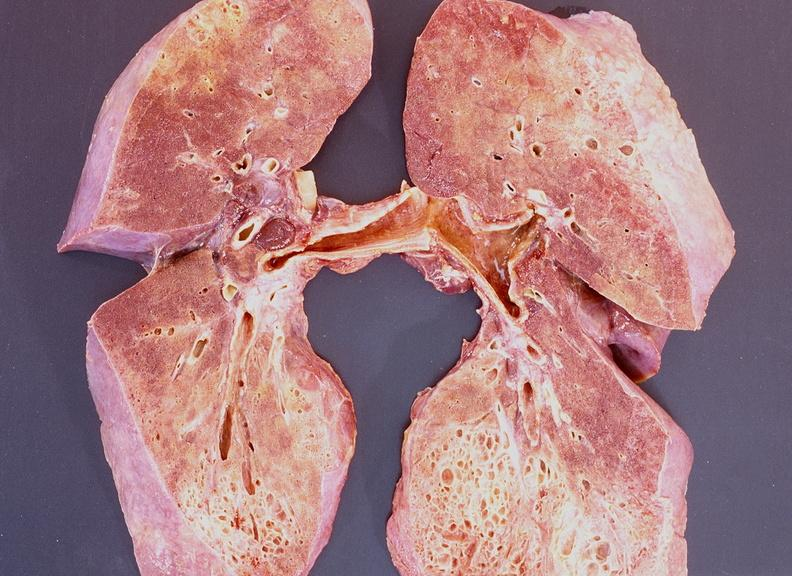where is this?
Answer the question using a single word or phrase. Lung 